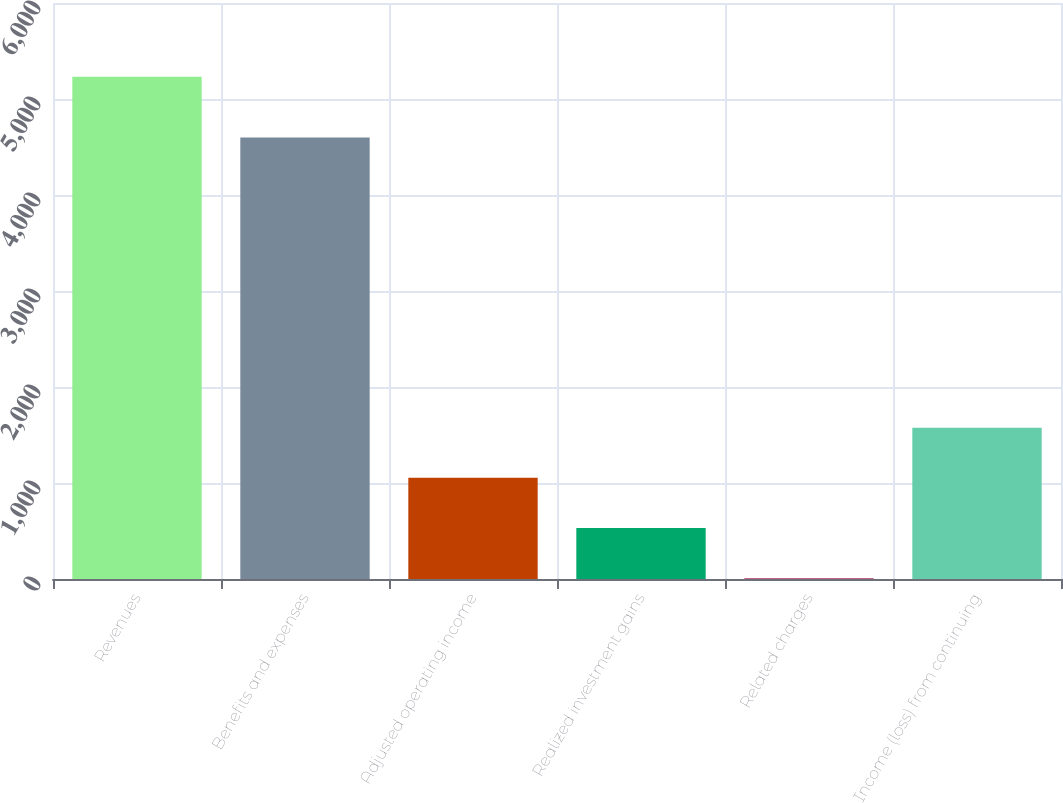Convert chart. <chart><loc_0><loc_0><loc_500><loc_500><bar_chart><fcel>Revenues<fcel>Benefits and expenses<fcel>Adjusted operating income<fcel>Realized investment gains<fcel>Related charges<fcel>Income (loss) from continuing<nl><fcel>5233<fcel>4598<fcel>1053.8<fcel>531.4<fcel>9<fcel>1576.2<nl></chart> 